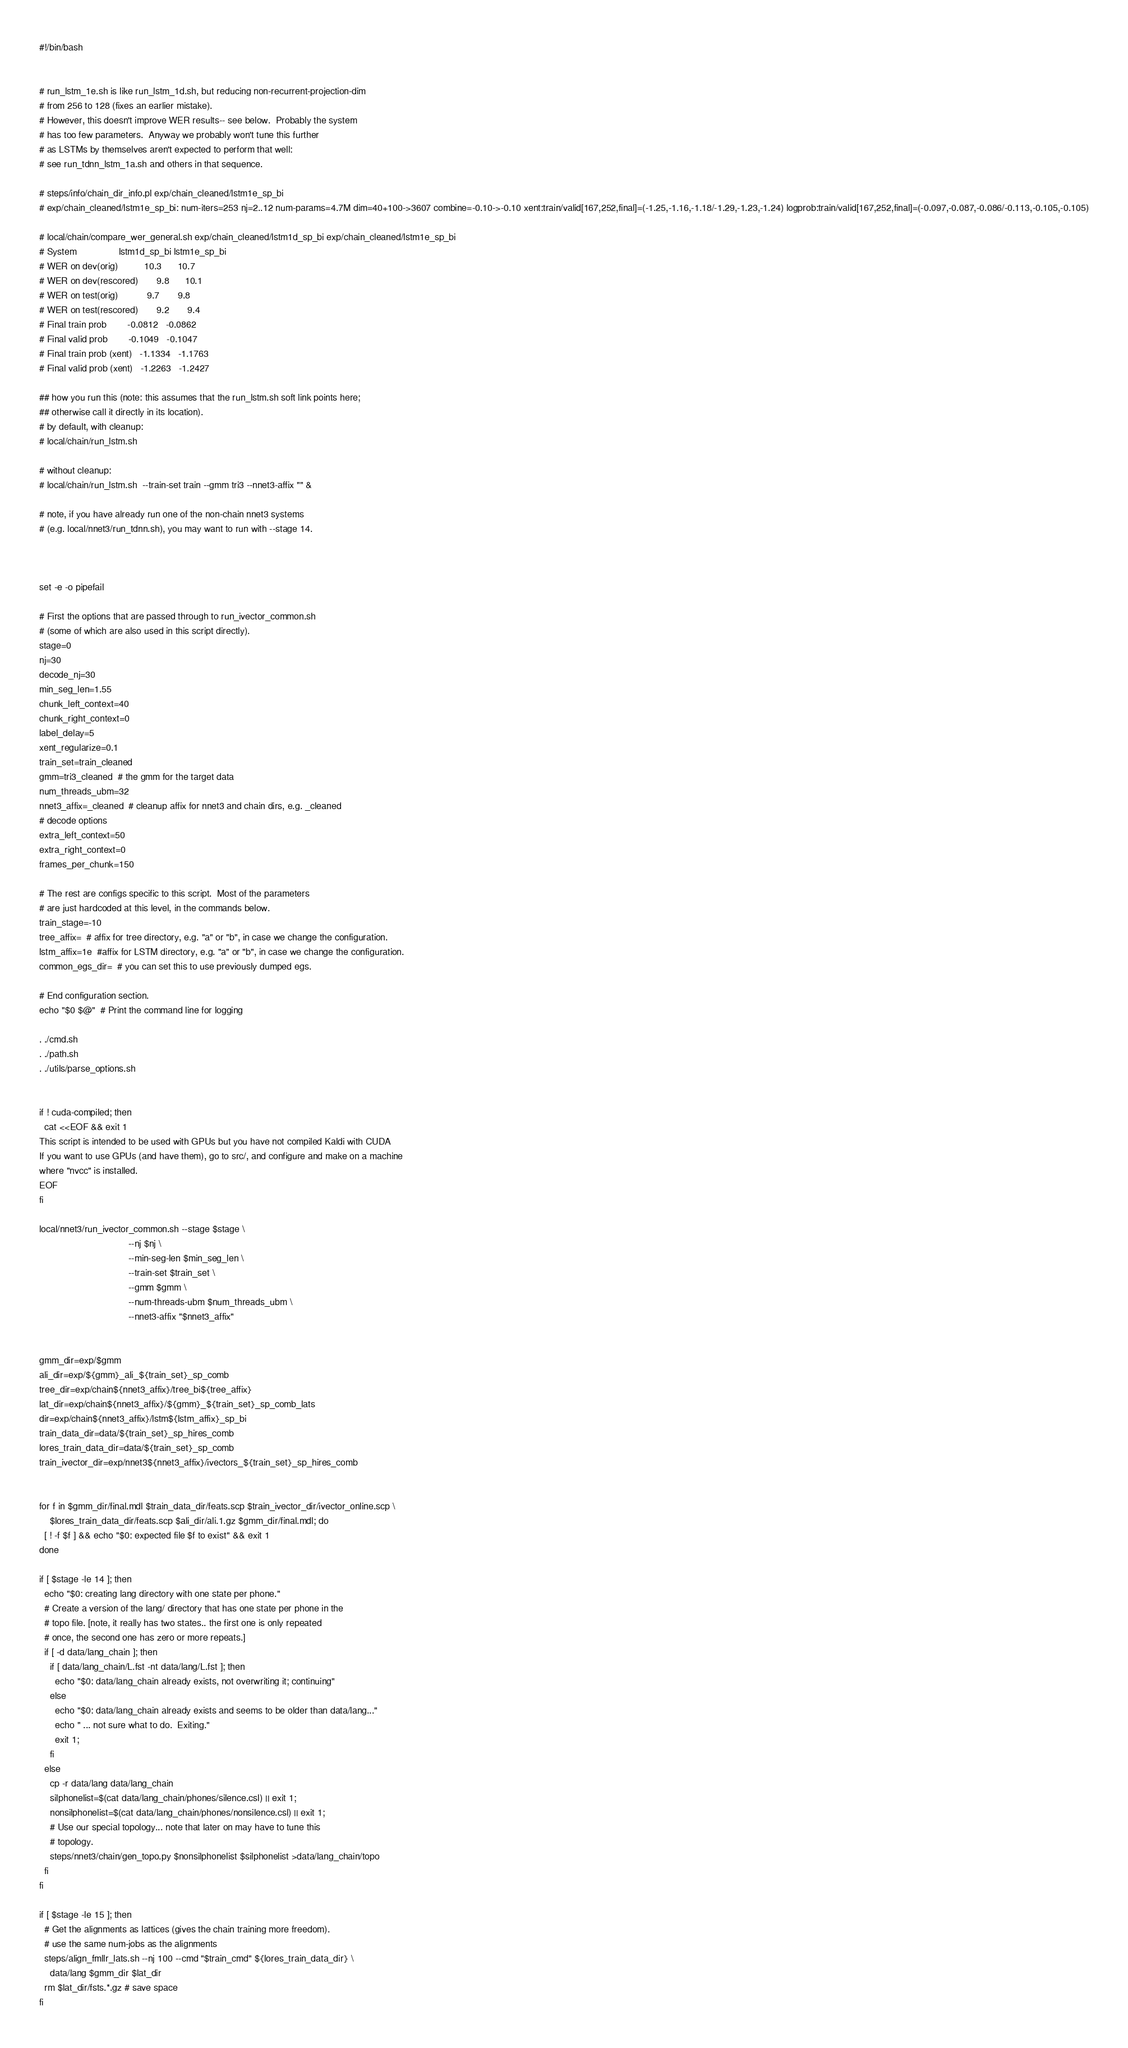<code> <loc_0><loc_0><loc_500><loc_500><_Bash_>#!/bin/bash


# run_lstm_1e.sh is like run_lstm_1d.sh, but reducing non-recurrent-projection-dim
# from 256 to 128 (fixes an earlier mistake).
# However, this doesn't improve WER results-- see below.  Probably the system
# has too few parameters.  Anyway we probably won't tune this further
# as LSTMs by themselves aren't expected to perform that well:
# see run_tdnn_lstm_1a.sh and others in that sequence.

# steps/info/chain_dir_info.pl exp/chain_cleaned/lstm1e_sp_bi
# exp/chain_cleaned/lstm1e_sp_bi: num-iters=253 nj=2..12 num-params=4.7M dim=40+100->3607 combine=-0.10->-0.10 xent:train/valid[167,252,final]=(-1.25,-1.16,-1.18/-1.29,-1.23,-1.24) logprob:train/valid[167,252,final]=(-0.097,-0.087,-0.086/-0.113,-0.105,-0.105)

# local/chain/compare_wer_general.sh exp/chain_cleaned/lstm1d_sp_bi exp/chain_cleaned/lstm1e_sp_bi
# System                lstm1d_sp_bi lstm1e_sp_bi
# WER on dev(orig)          10.3      10.7
# WER on dev(rescored)       9.8      10.1
# WER on test(orig)           9.7       9.8
# WER on test(rescored)       9.2       9.4
# Final train prob        -0.0812   -0.0862
# Final valid prob        -0.1049   -0.1047
# Final train prob (xent)   -1.1334   -1.1763
# Final valid prob (xent)   -1.2263   -1.2427

## how you run this (note: this assumes that the run_lstm.sh soft link points here;
## otherwise call it directly in its location).
# by default, with cleanup:
# local/chain/run_lstm.sh

# without cleanup:
# local/chain/run_lstm.sh  --train-set train --gmm tri3 --nnet3-affix "" &

# note, if you have already run one of the non-chain nnet3 systems
# (e.g. local/nnet3/run_tdnn.sh), you may want to run with --stage 14.



set -e -o pipefail

# First the options that are passed through to run_ivector_common.sh
# (some of which are also used in this script directly).
stage=0
nj=30
decode_nj=30
min_seg_len=1.55
chunk_left_context=40
chunk_right_context=0
label_delay=5
xent_regularize=0.1
train_set=train_cleaned
gmm=tri3_cleaned  # the gmm for the target data
num_threads_ubm=32
nnet3_affix=_cleaned  # cleanup affix for nnet3 and chain dirs, e.g. _cleaned
# decode options
extra_left_context=50
extra_right_context=0
frames_per_chunk=150

# The rest are configs specific to this script.  Most of the parameters
# are just hardcoded at this level, in the commands below.
train_stage=-10
tree_affix=  # affix for tree directory, e.g. "a" or "b", in case we change the configuration.
lstm_affix=1e  #affix for LSTM directory, e.g. "a" or "b", in case we change the configuration.
common_egs_dir=  # you can set this to use previously dumped egs.

# End configuration section.
echo "$0 $@"  # Print the command line for logging

. ./cmd.sh
. ./path.sh
. ./utils/parse_options.sh


if ! cuda-compiled; then
  cat <<EOF && exit 1
This script is intended to be used with GPUs but you have not compiled Kaldi with CUDA
If you want to use GPUs (and have them), go to src/, and configure and make on a machine
where "nvcc" is installed.
EOF
fi

local/nnet3/run_ivector_common.sh --stage $stage \
                                  --nj $nj \
                                  --min-seg-len $min_seg_len \
                                  --train-set $train_set \
                                  --gmm $gmm \
                                  --num-threads-ubm $num_threads_ubm \
                                  --nnet3-affix "$nnet3_affix"


gmm_dir=exp/$gmm
ali_dir=exp/${gmm}_ali_${train_set}_sp_comb
tree_dir=exp/chain${nnet3_affix}/tree_bi${tree_affix}
lat_dir=exp/chain${nnet3_affix}/${gmm}_${train_set}_sp_comb_lats
dir=exp/chain${nnet3_affix}/lstm${lstm_affix}_sp_bi
train_data_dir=data/${train_set}_sp_hires_comb
lores_train_data_dir=data/${train_set}_sp_comb
train_ivector_dir=exp/nnet3${nnet3_affix}/ivectors_${train_set}_sp_hires_comb


for f in $gmm_dir/final.mdl $train_data_dir/feats.scp $train_ivector_dir/ivector_online.scp \
    $lores_train_data_dir/feats.scp $ali_dir/ali.1.gz $gmm_dir/final.mdl; do
  [ ! -f $f ] && echo "$0: expected file $f to exist" && exit 1
done

if [ $stage -le 14 ]; then
  echo "$0: creating lang directory with one state per phone."
  # Create a version of the lang/ directory that has one state per phone in the
  # topo file. [note, it really has two states.. the first one is only repeated
  # once, the second one has zero or more repeats.]
  if [ -d data/lang_chain ]; then
    if [ data/lang_chain/L.fst -nt data/lang/L.fst ]; then
      echo "$0: data/lang_chain already exists, not overwriting it; continuing"
    else
      echo "$0: data/lang_chain already exists and seems to be older than data/lang..."
      echo " ... not sure what to do.  Exiting."
      exit 1;
    fi
  else
    cp -r data/lang data/lang_chain
    silphonelist=$(cat data/lang_chain/phones/silence.csl) || exit 1;
    nonsilphonelist=$(cat data/lang_chain/phones/nonsilence.csl) || exit 1;
    # Use our special topology... note that later on may have to tune this
    # topology.
    steps/nnet3/chain/gen_topo.py $nonsilphonelist $silphonelist >data/lang_chain/topo
  fi
fi

if [ $stage -le 15 ]; then
  # Get the alignments as lattices (gives the chain training more freedom).
  # use the same num-jobs as the alignments
  steps/align_fmllr_lats.sh --nj 100 --cmd "$train_cmd" ${lores_train_data_dir} \
    data/lang $gmm_dir $lat_dir
  rm $lat_dir/fsts.*.gz # save space
fi
</code> 